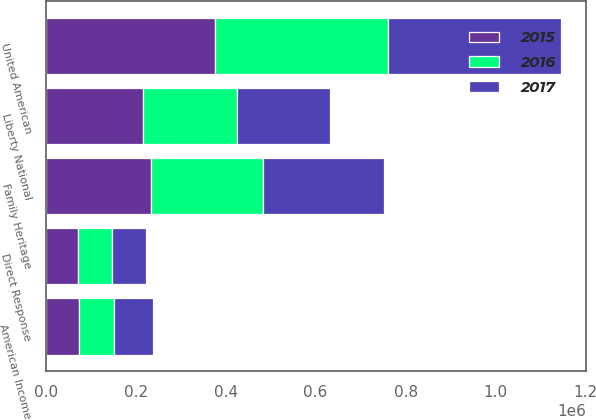Convert chart to OTSL. <chart><loc_0><loc_0><loc_500><loc_500><stacked_bar_chart><ecel><fcel>Direct Response<fcel>Liberty National<fcel>American Income<fcel>Family Heritage<fcel>United American<nl><fcel>2017<fcel>76672<fcel>205136<fcel>84775<fcel>268584<fcel>382853<nl><fcel>2016<fcel>74261<fcel>210260<fcel>78947<fcel>249857<fcel>385309<nl><fcel>2015<fcel>72423<fcel>216139<fcel>74058<fcel>234120<fcel>376302<nl></chart> 